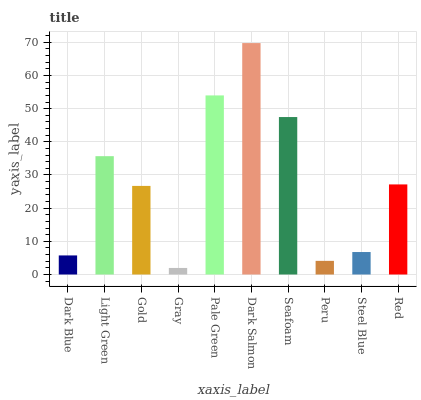Is Gray the minimum?
Answer yes or no. Yes. Is Dark Salmon the maximum?
Answer yes or no. Yes. Is Light Green the minimum?
Answer yes or no. No. Is Light Green the maximum?
Answer yes or no. No. Is Light Green greater than Dark Blue?
Answer yes or no. Yes. Is Dark Blue less than Light Green?
Answer yes or no. Yes. Is Dark Blue greater than Light Green?
Answer yes or no. No. Is Light Green less than Dark Blue?
Answer yes or no. No. Is Red the high median?
Answer yes or no. Yes. Is Gold the low median?
Answer yes or no. Yes. Is Seafoam the high median?
Answer yes or no. No. Is Seafoam the low median?
Answer yes or no. No. 